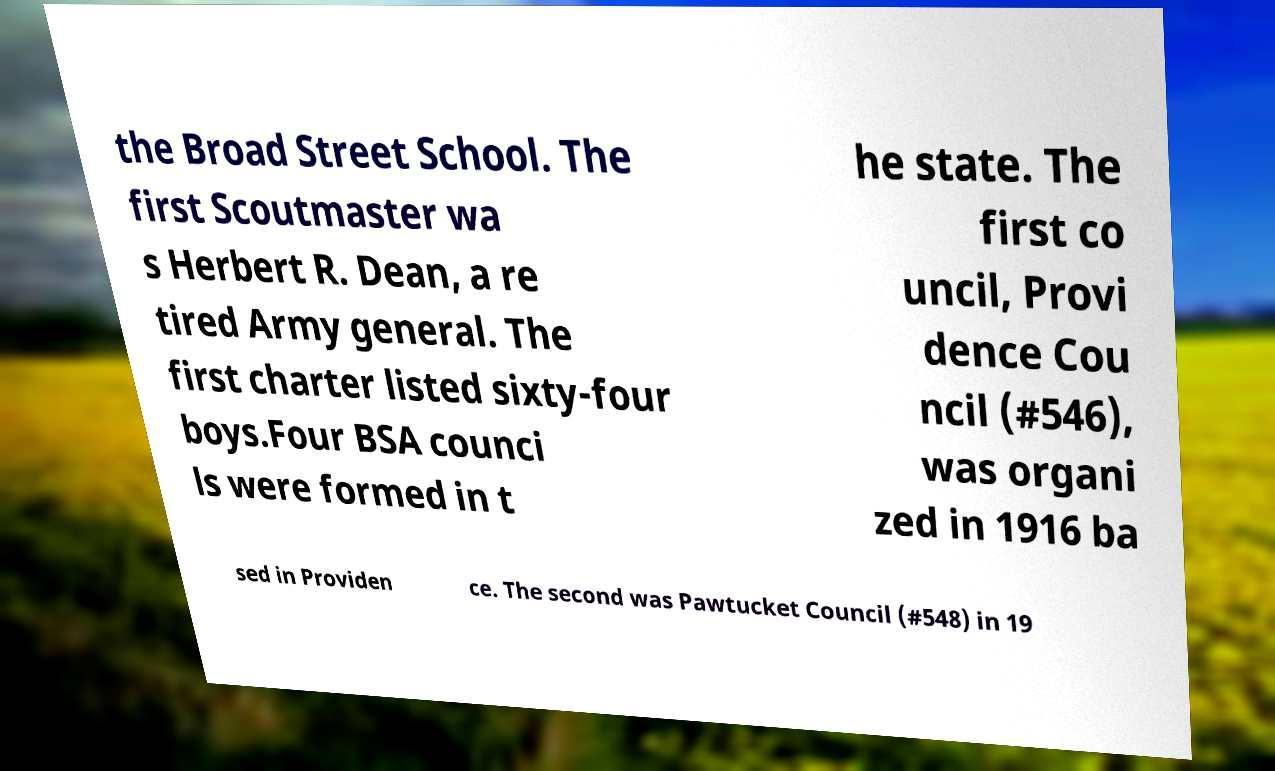Could you assist in decoding the text presented in this image and type it out clearly? the Broad Street School. The first Scoutmaster wa s Herbert R. Dean, a re tired Army general. The first charter listed sixty-four boys.Four BSA counci ls were formed in t he state. The first co uncil, Provi dence Cou ncil (#546), was organi zed in 1916 ba sed in Providen ce. The second was Pawtucket Council (#548) in 19 